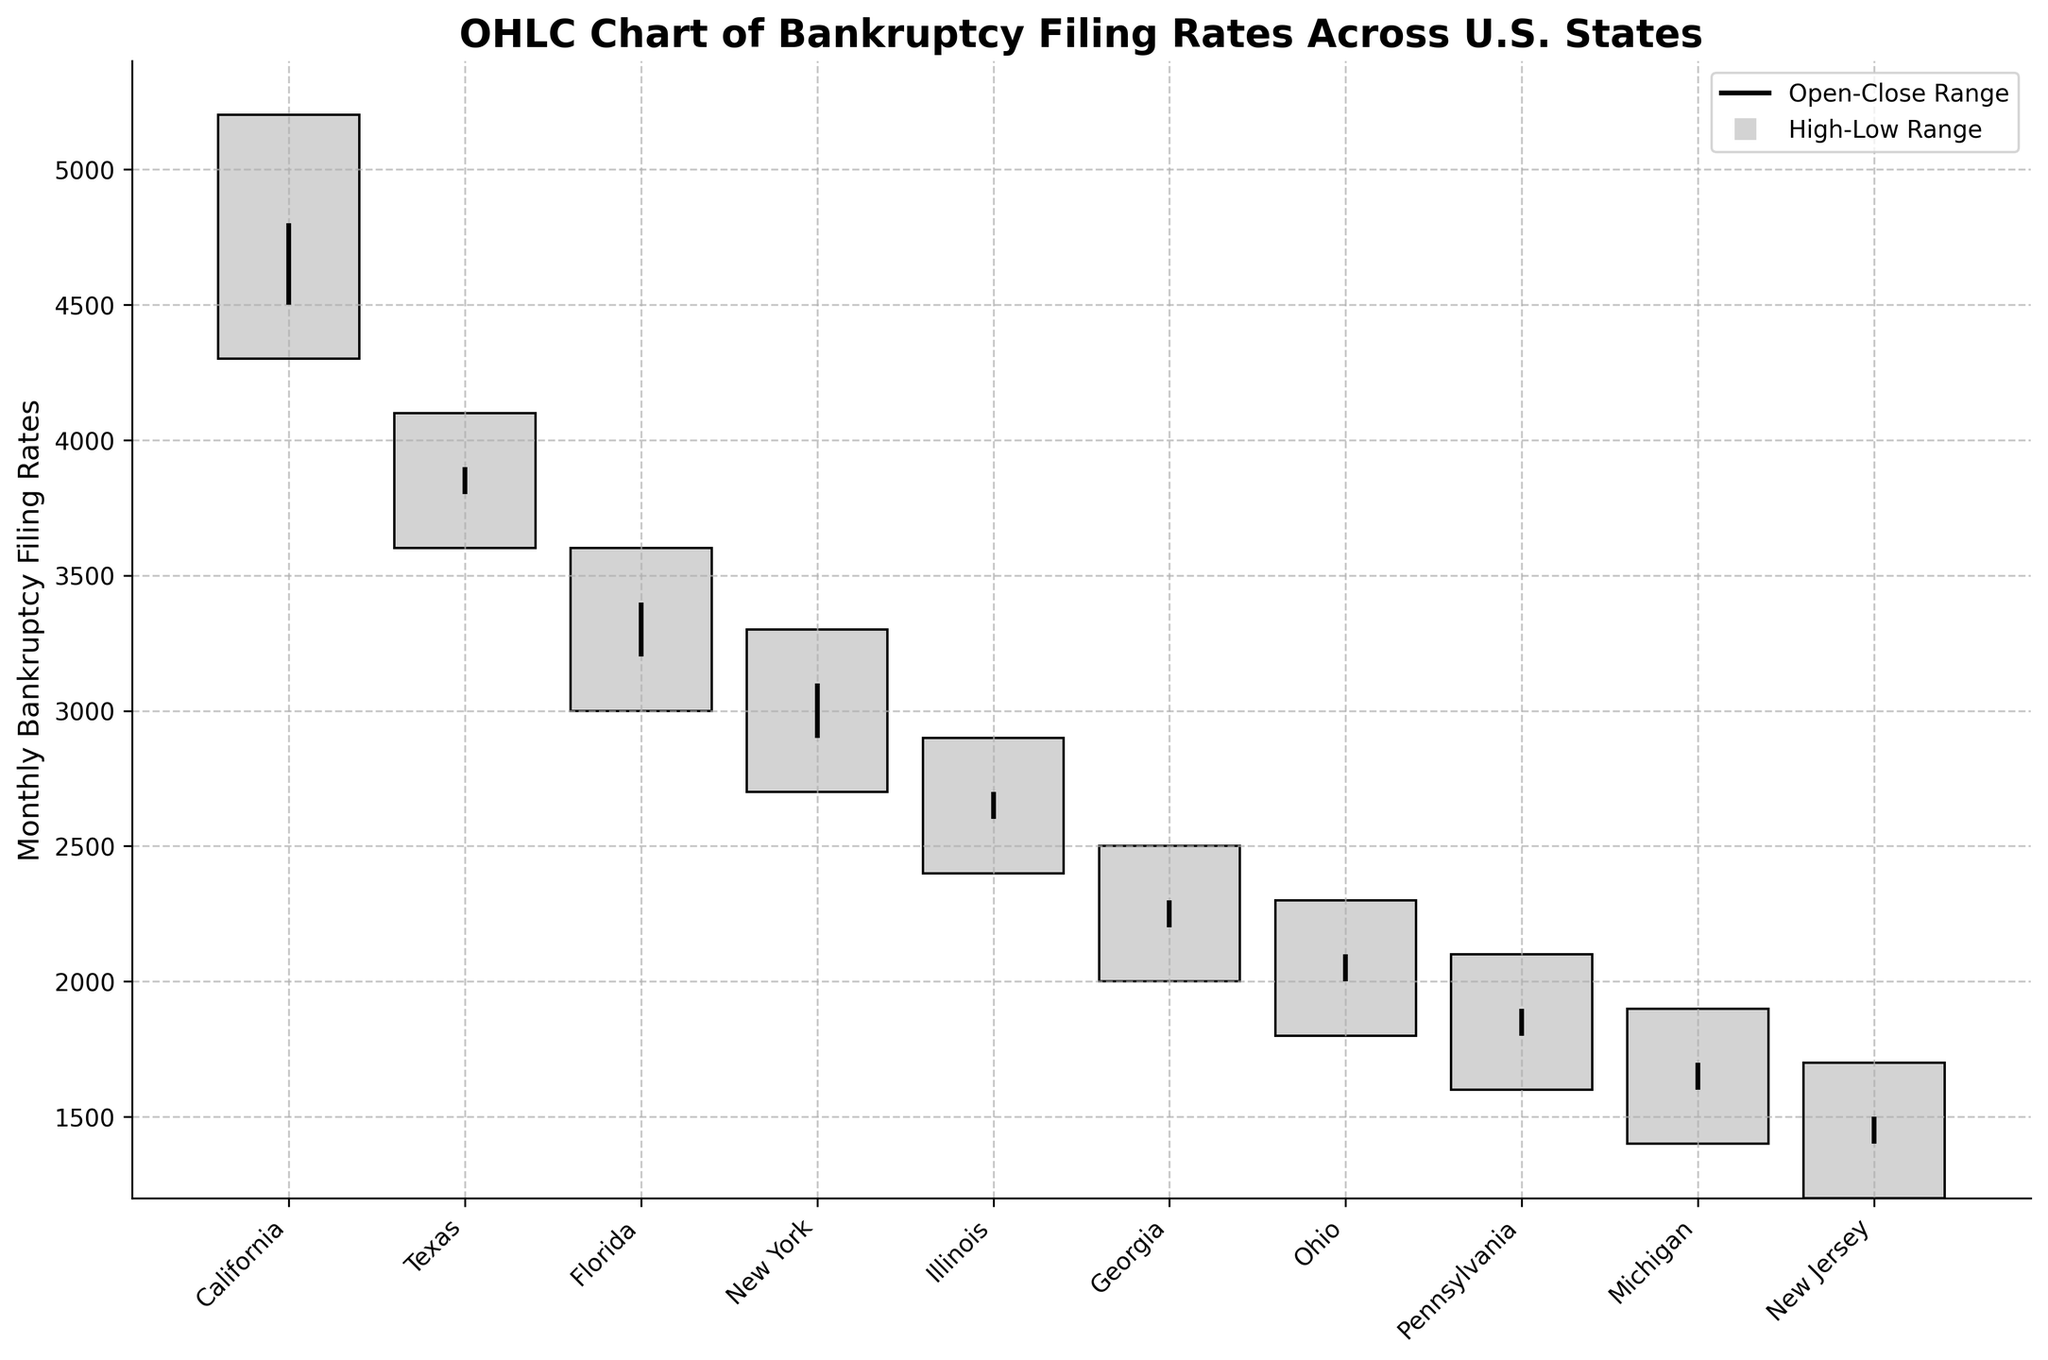What's the title of the chart? The title is usually located at the top of the chart, describing what the chart is about. In this case, it clearly states that the chart is about the "OHLC Chart of Bankruptcy Filing Rates Across U.S. States."
Answer: OHLC Chart of Bankruptcy Filing Rates Across U.S. States Which state has the highest monthly bankruptcy filing rate at any point? To find this, look at the highest value (High) for each state. California has the highest value at 5200.
Answer: California For Texas, what is the difference between the highest and lowest bankruptcy filing rates? The difference is calculated by subtracting the lowest value (Low) from the highest value (High) for Texas. So, 4100 - 3600 = 500.
Answer: 500 How many states have a monthly bankruptcy filing rate (Close) higher than 3000? By looking at the Close values, states with a rate higher than 3000 are California (4800), Texas (3900), Florida (3400), and New York (3100). So, there are 4 such states.
Answer: 4 Which state has the smallest range between its highest and lowest monthly filing rates? The range is calculated by subtracting the Low value from the High value for each state. New Jersey has the smallest range with High = 1700 and Low = 1200, so 1700 - 1200 = 500.
Answer: New Jersey Compare the open and close values for Ohio. Does the rate increase or decrease? Comparing the Open (2000) and Close (2100) values for Ohio shows that the rate increases.
Answer: Increases What are the axis labels used in the chart? The x-axis usually labels the categories; in this case, it's the U.S. states. The y-axis measures the "Monthly Bankruptcy Filing Rates."
Answer: States and Monthly Bankruptcy Filing Rates What is the average closing value across all the states? To calculate the average closing value, sum all the Close values and divide by the number of states. (4800 + 3900 + 3400 + 3100 + 2700 + 2300 + 2100 + 1900 + 1700 + 1500) / 10 = 27400 / 10 = 2740.
Answer: 2740 